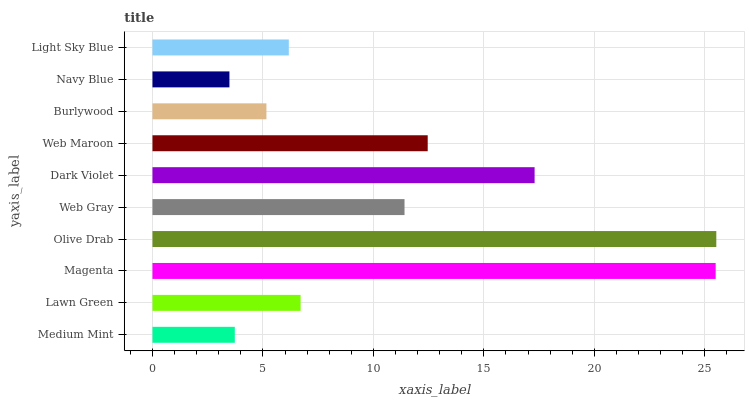Is Navy Blue the minimum?
Answer yes or no. Yes. Is Olive Drab the maximum?
Answer yes or no. Yes. Is Lawn Green the minimum?
Answer yes or no. No. Is Lawn Green the maximum?
Answer yes or no. No. Is Lawn Green greater than Medium Mint?
Answer yes or no. Yes. Is Medium Mint less than Lawn Green?
Answer yes or no. Yes. Is Medium Mint greater than Lawn Green?
Answer yes or no. No. Is Lawn Green less than Medium Mint?
Answer yes or no. No. Is Web Gray the high median?
Answer yes or no. Yes. Is Lawn Green the low median?
Answer yes or no. Yes. Is Magenta the high median?
Answer yes or no. No. Is Light Sky Blue the low median?
Answer yes or no. No. 